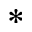<formula> <loc_0><loc_0><loc_500><loc_500>\ast</formula> 